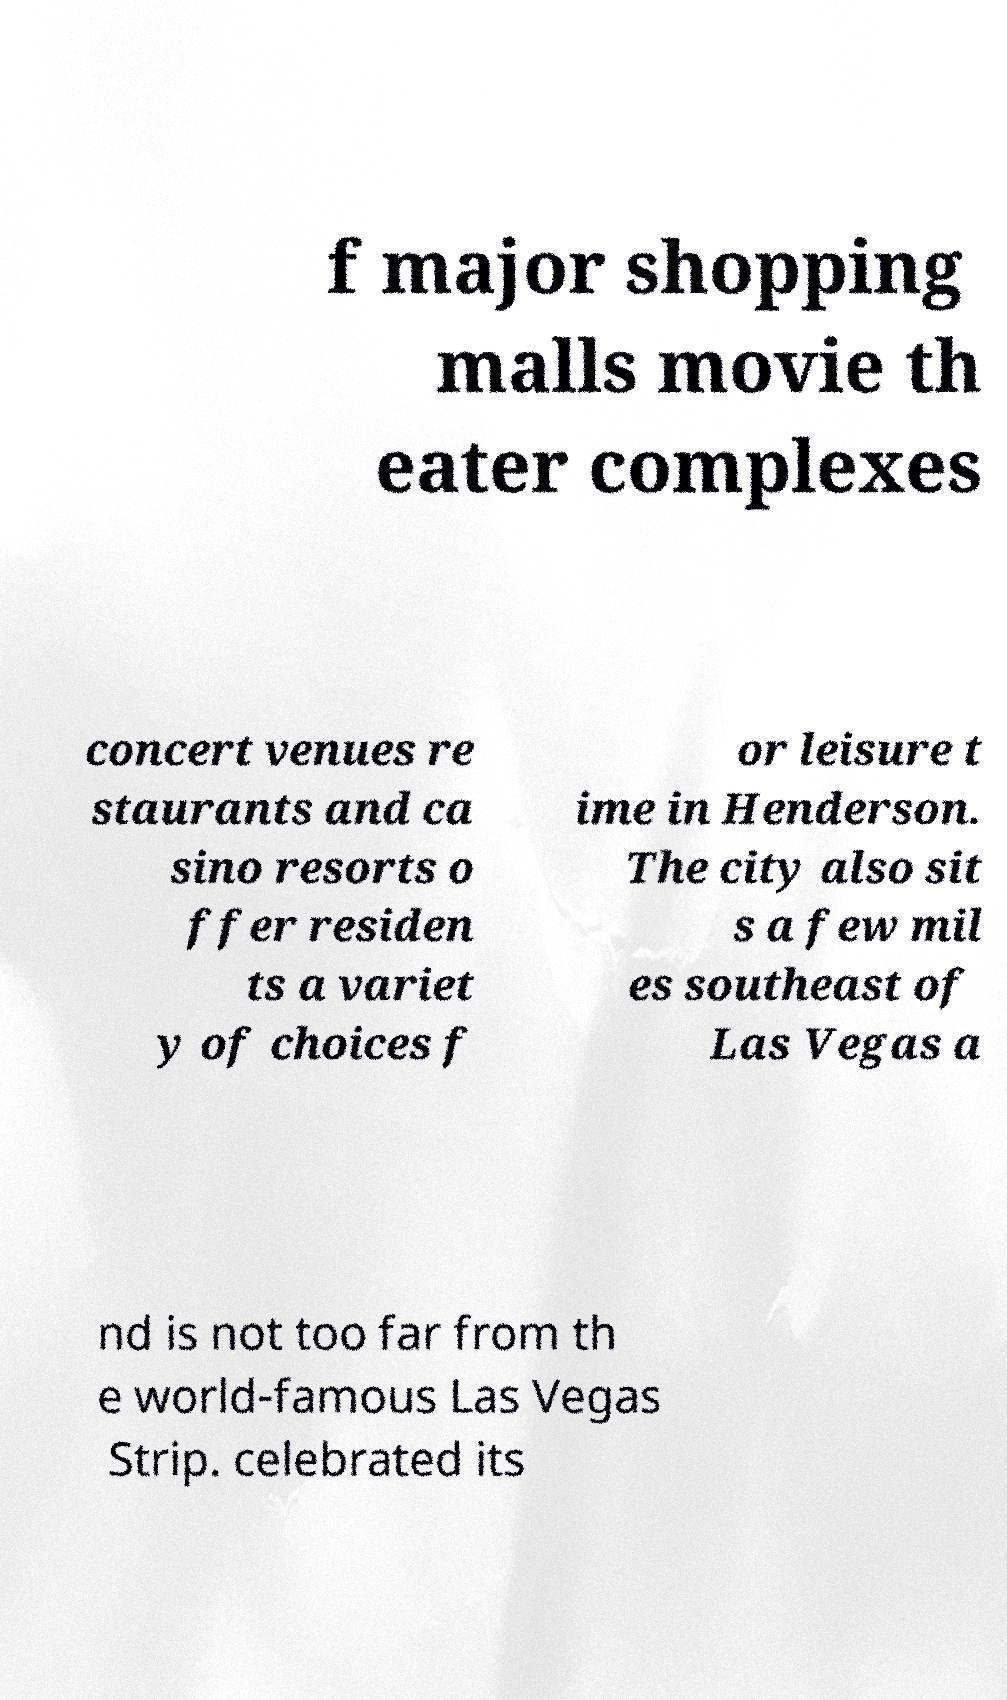Please read and relay the text visible in this image. What does it say? f major shopping malls movie th eater complexes concert venues re staurants and ca sino resorts o ffer residen ts a variet y of choices f or leisure t ime in Henderson. The city also sit s a few mil es southeast of Las Vegas a nd is not too far from th e world-famous Las Vegas Strip. celebrated its 